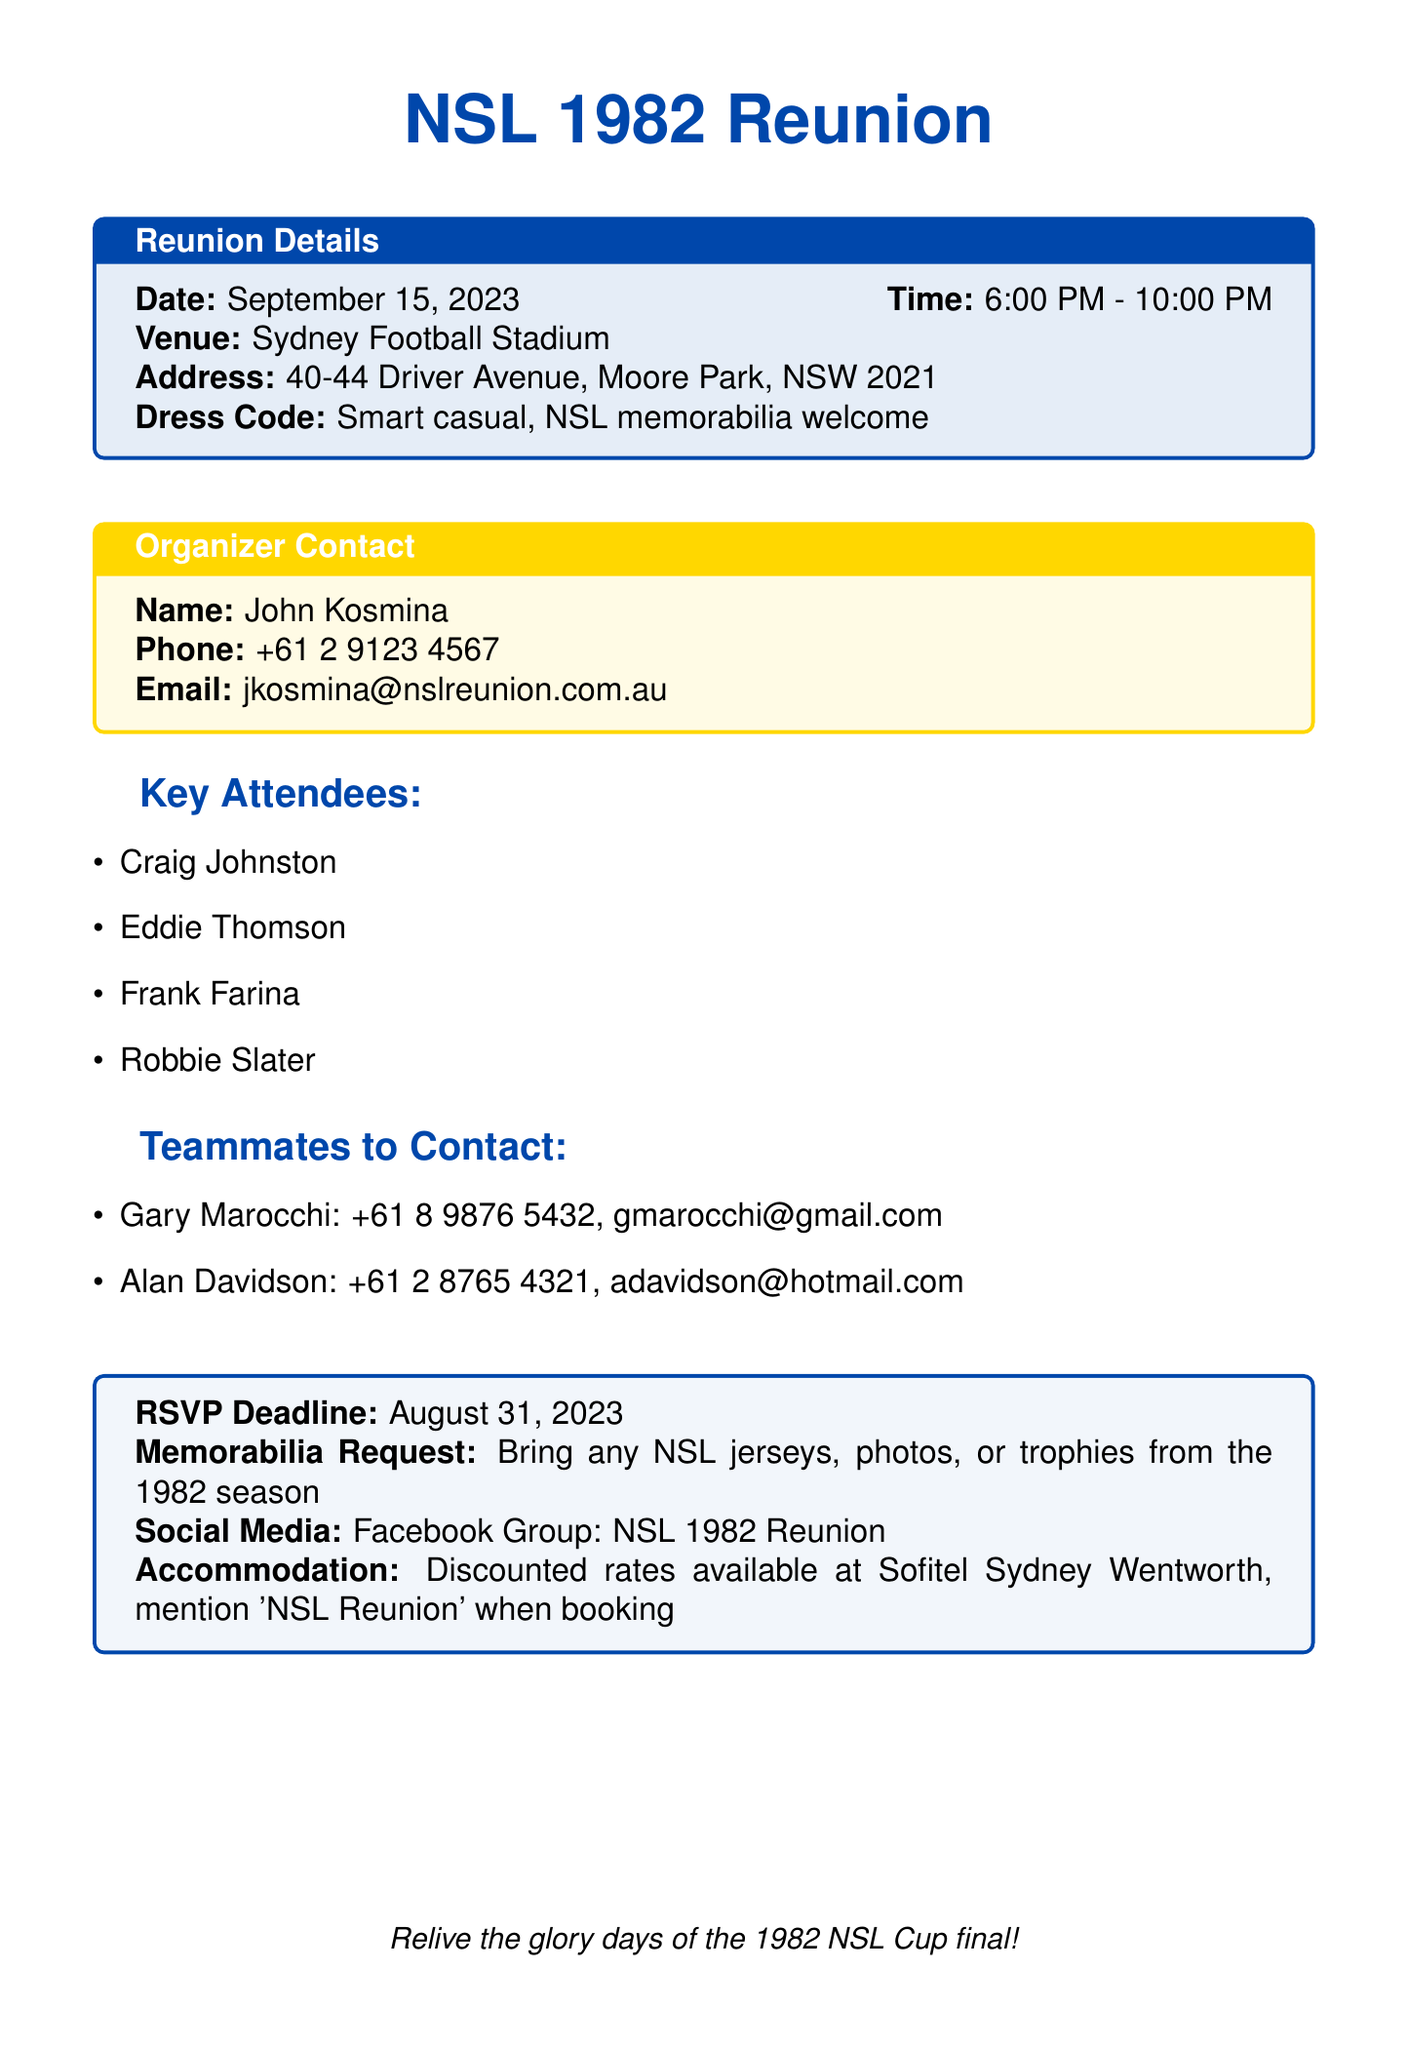What is the date of the reunion? The date of the reunion is clearly stated in the document as September 15, 2023.
Answer: September 15, 2023 What is the dress code for the reunion? The dress code is explicitly mentioned in the document, which is smart casual with NSL memorabilia welcome.
Answer: Smart casual, NSL memorabilia welcome Who is the organizer of the reunion? The document lists John Kosmina as the name of the organizer in the contact information section.
Answer: John Kosmina What is the RSVP deadline? The RSVP deadline is provided in the document and is set for August 31, 2023.
Answer: August 31, 2023 Which venue is hosting the reunion? The venue for the reunion is specified in the reunion details section as the Sydney Football Stadium.
Answer: Sydney Football Stadium How many key attendees are listed? The document includes a list of key attendees, and there are four names mentioned in that section.
Answer: Four What should attendees bring for memorabilia? The document requests attendees to bring any NSL jerseys, photos, or trophies from the 1982 season.
Answer: Any NSL jerseys, photos, or trophies from the 1982 season What is the accommodation information provided? The document states that discounted rates are available at the Sofitel Sydney Wentworth by mentioning 'NSL Reunion' when booking.
Answer: Discounted rates at Sofitel Sydney Wentworth What social media group is mentioned for the reunion? The document mentions a Facebook group for the reunion, which is for NSL 1982 Reunion.
Answer: NSL 1982 Reunion 